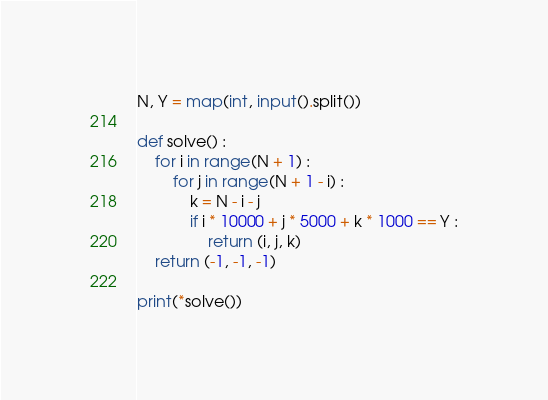<code> <loc_0><loc_0><loc_500><loc_500><_Python_>N, Y = map(int, input().split())

def solve() :
    for i in range(N + 1) :
        for j in range(N + 1 - i) :
            k = N - i - j
            if i * 10000 + j * 5000 + k * 1000 == Y :
                return (i, j, k)
    return (-1, -1, -1)
    
print(*solve())</code> 